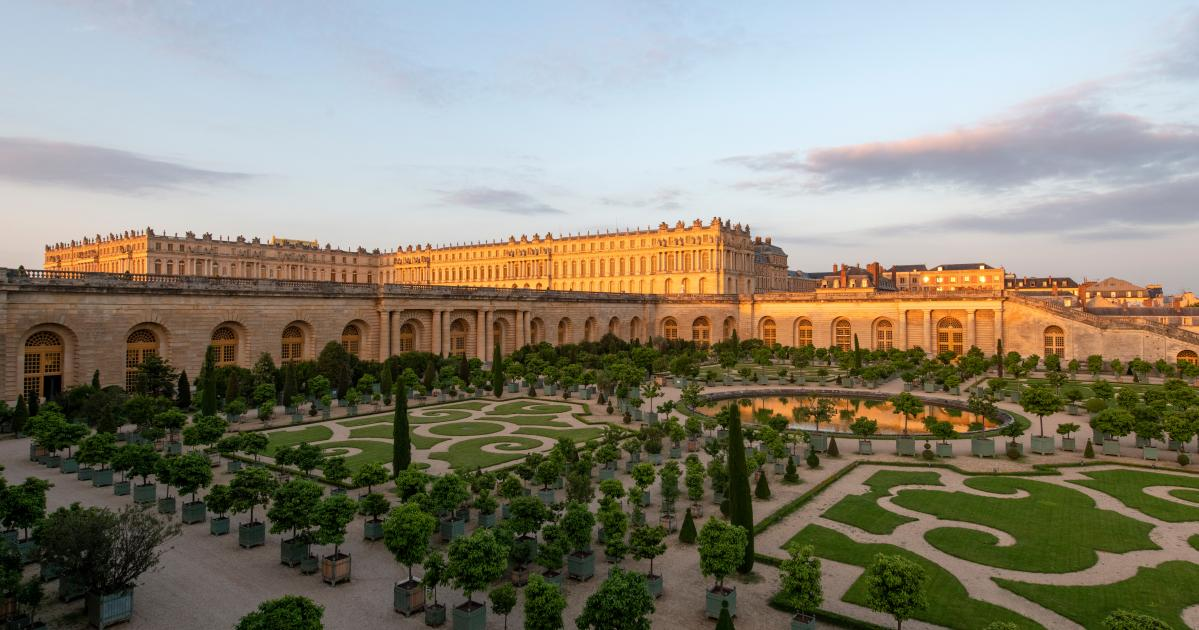Could you describe a historical event that might have taken place in this palace? One of the most significant historical events that took place in the Palace of Versailles is the signing of the Treaty of Versailles in 1919. This treaty, signed in the Hall of Mirrors, officially ended World War I and imposed significant penalties and restrictions on Germany. The Hall of Mirrors, with its stunning array of mirrors reflecting the light from its grand chandeliers, provided a breathtaking and dramatic backdrop for this momentous occasion in world history. 